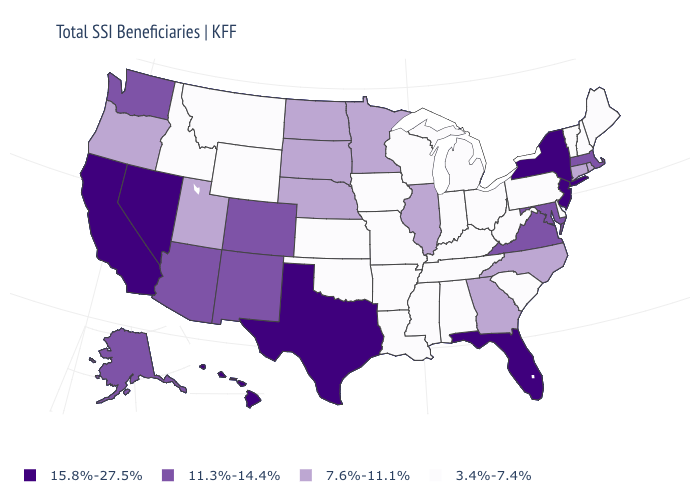Name the states that have a value in the range 7.6%-11.1%?
Keep it brief. Connecticut, Georgia, Illinois, Minnesota, Nebraska, North Carolina, North Dakota, Oregon, Rhode Island, South Dakota, Utah. Name the states that have a value in the range 11.3%-14.4%?
Give a very brief answer. Alaska, Arizona, Colorado, Maryland, Massachusetts, New Mexico, Virginia, Washington. Among the states that border Oregon , which have the lowest value?
Keep it brief. Idaho. Among the states that border Nevada , which have the lowest value?
Quick response, please. Idaho. Which states have the lowest value in the USA?
Short answer required. Alabama, Arkansas, Delaware, Idaho, Indiana, Iowa, Kansas, Kentucky, Louisiana, Maine, Michigan, Mississippi, Missouri, Montana, New Hampshire, Ohio, Oklahoma, Pennsylvania, South Carolina, Tennessee, Vermont, West Virginia, Wisconsin, Wyoming. What is the value of Iowa?
Quick response, please. 3.4%-7.4%. Does Wyoming have the lowest value in the West?
Write a very short answer. Yes. Which states have the lowest value in the USA?
Short answer required. Alabama, Arkansas, Delaware, Idaho, Indiana, Iowa, Kansas, Kentucky, Louisiana, Maine, Michigan, Mississippi, Missouri, Montana, New Hampshire, Ohio, Oklahoma, Pennsylvania, South Carolina, Tennessee, Vermont, West Virginia, Wisconsin, Wyoming. What is the value of New Hampshire?
Keep it brief. 3.4%-7.4%. Among the states that border Washington , does Idaho have the highest value?
Give a very brief answer. No. Name the states that have a value in the range 15.8%-27.5%?
Answer briefly. California, Florida, Hawaii, Nevada, New Jersey, New York, Texas. Among the states that border Arizona , does Nevada have the highest value?
Answer briefly. Yes. Name the states that have a value in the range 3.4%-7.4%?
Keep it brief. Alabama, Arkansas, Delaware, Idaho, Indiana, Iowa, Kansas, Kentucky, Louisiana, Maine, Michigan, Mississippi, Missouri, Montana, New Hampshire, Ohio, Oklahoma, Pennsylvania, South Carolina, Tennessee, Vermont, West Virginia, Wisconsin, Wyoming. Does New Jersey have the lowest value in the USA?
Write a very short answer. No. Is the legend a continuous bar?
Answer briefly. No. 